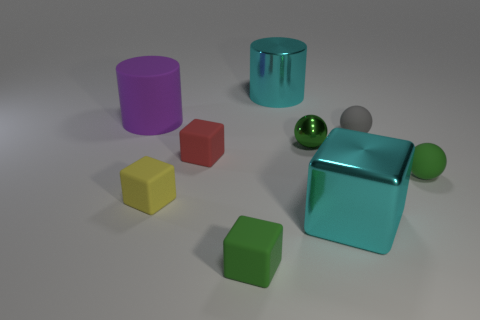Is there any other thing that has the same shape as the tiny yellow object?
Your response must be concise. Yes. Is the big cylinder to the left of the cyan cylinder made of the same material as the red cube?
Your response must be concise. Yes. What is the material of the other cylinder that is the same size as the shiny cylinder?
Provide a short and direct response. Rubber. How many other things are there of the same material as the gray object?
Provide a succinct answer. 5. Is the size of the purple rubber cylinder the same as the green ball in front of the red thing?
Keep it short and to the point. No. Are there fewer rubber cylinders behind the matte cylinder than tiny rubber objects that are behind the big cyan metallic block?
Ensure brevity in your answer.  Yes. There is a cylinder on the right side of the small red rubber block; what is its size?
Your answer should be very brief. Large. Does the metallic ball have the same size as the purple matte object?
Make the answer very short. No. What number of matte objects are both in front of the green matte sphere and to the left of the small red matte cube?
Offer a terse response. 1. How many cyan things are small matte cylinders or metallic cylinders?
Make the answer very short. 1. 